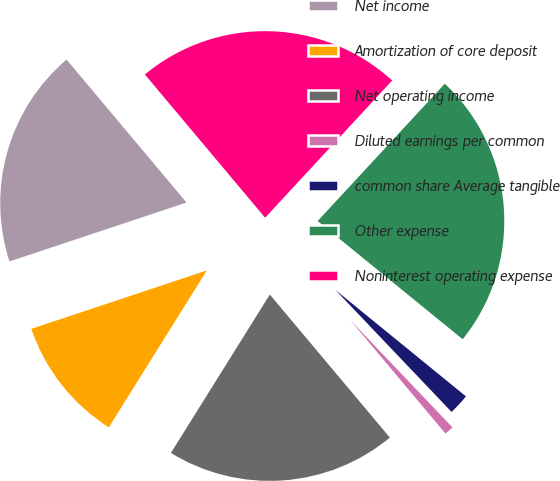Convert chart to OTSL. <chart><loc_0><loc_0><loc_500><loc_500><pie_chart><fcel>Net income<fcel>Amortization of core deposit<fcel>Net operating income<fcel>Diluted earnings per common<fcel>common share Average tangible<fcel>Other expense<fcel>Noninterest operating expense<nl><fcel>19.0%<fcel>11.0%<fcel>20.0%<fcel>1.0%<fcel>2.0%<fcel>24.0%<fcel>23.0%<nl></chart> 